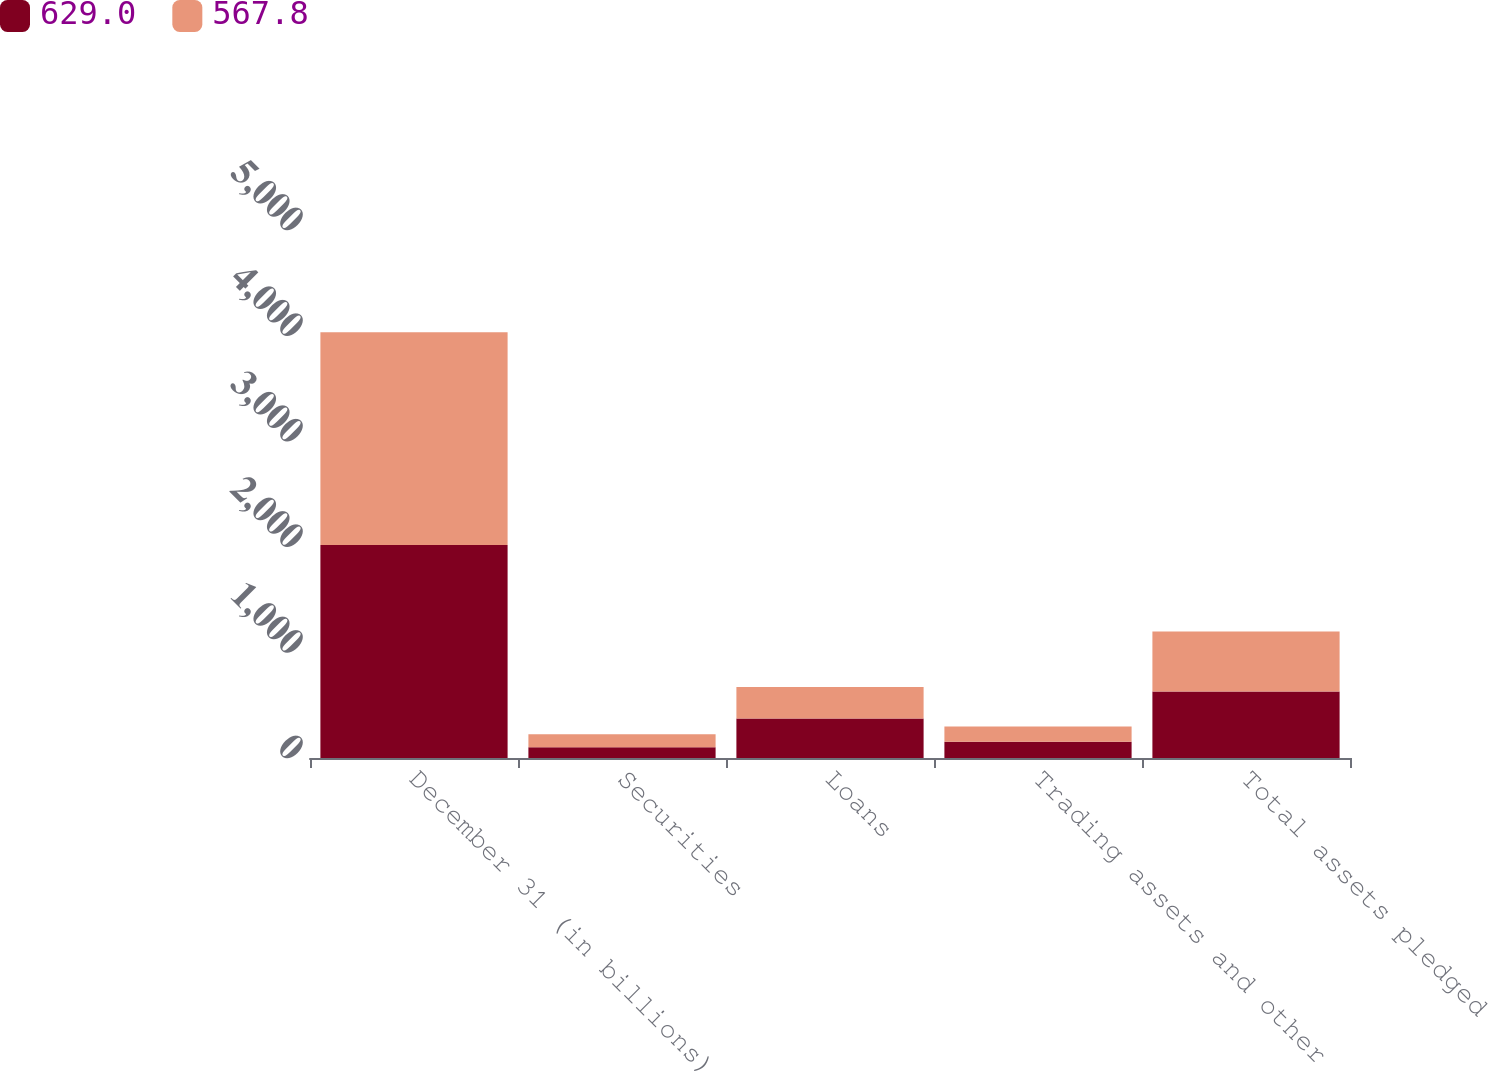Convert chart. <chart><loc_0><loc_0><loc_500><loc_500><stacked_bar_chart><ecel><fcel>December 31 (in billions)<fcel>Securities<fcel>Loans<fcel>Trading assets and other<fcel>Total assets pledged<nl><fcel>629<fcel>2016<fcel>101.1<fcel>374.9<fcel>153<fcel>629<nl><fcel>567.8<fcel>2015<fcel>124.3<fcel>298.6<fcel>144.9<fcel>567.8<nl></chart> 